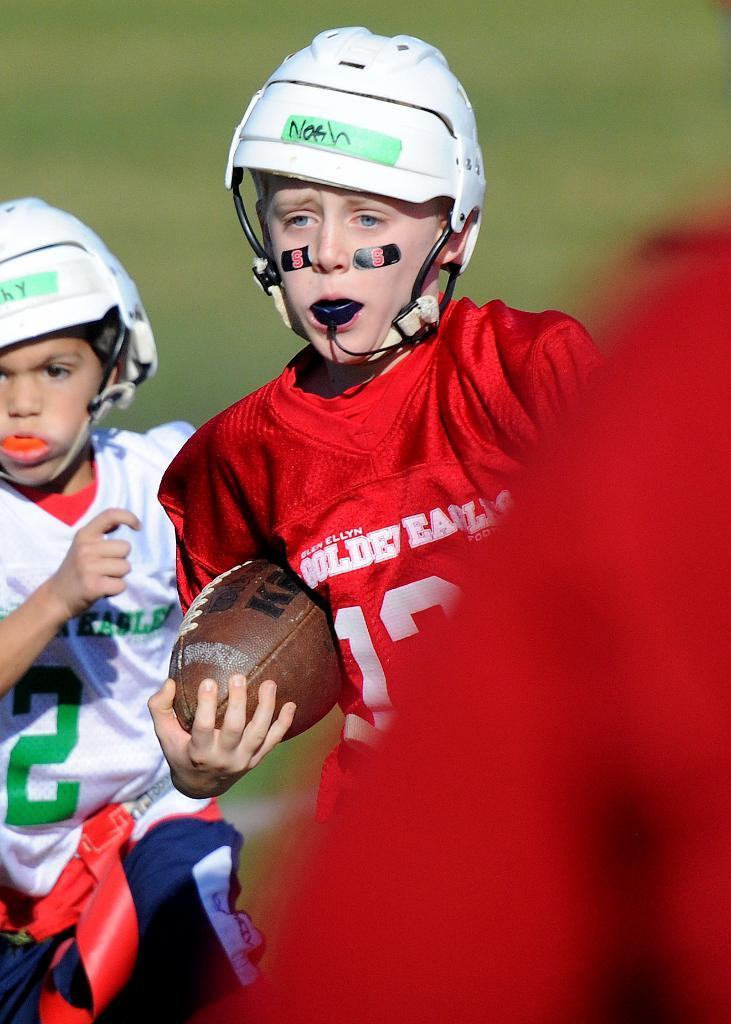What is the boy in the image wearing on his head? The boy is wearing a helmet in the image. What is the boy holding in the image? The boy is holding an American football in the image. Are there any other boys in the image? Yes, there is another boy wearing a helmet in the image. What do both boys have in their mouths? Both boys have something in their mouths in the image. Can you describe the background of the image? The background of the image is blurred. How many spoons can be seen in the image? There are no spoons present in the image. What is the limit of snails that can be seen in the image? There are no snails present in the image. 